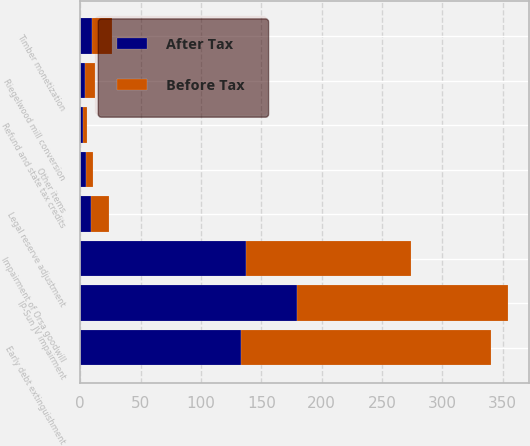<chart> <loc_0><loc_0><loc_500><loc_500><stacked_bar_chart><ecel><fcel>Riegelwood mill conversion<fcel>Timber monetization<fcel>Early debt extinguishment<fcel>IP-Sun JV impairment<fcel>Legal reserve adjustment<fcel>Refund and state tax credits<fcel>Impairment of Orsa goodwill<fcel>Other items<nl><fcel>Before Tax<fcel>8<fcel>16<fcel>207<fcel>174<fcel>15<fcel>4<fcel>137<fcel>6<nl><fcel>After Tax<fcel>4<fcel>10<fcel>133<fcel>180<fcel>9<fcel>2<fcel>137<fcel>5<nl></chart> 